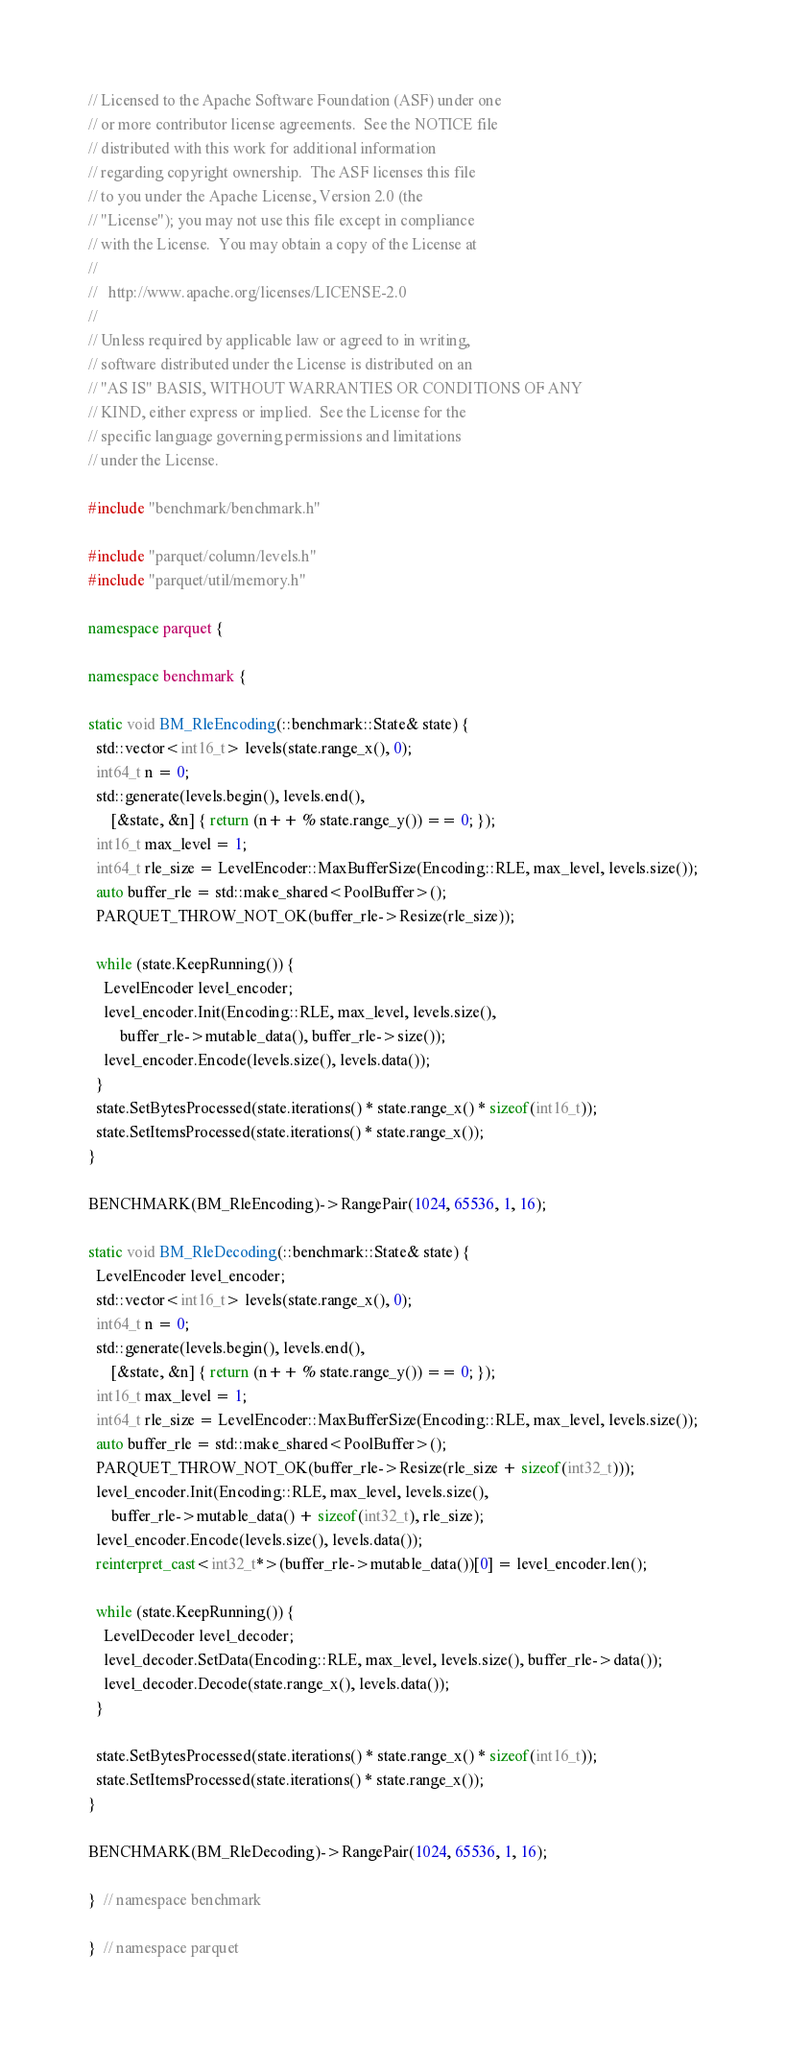<code> <loc_0><loc_0><loc_500><loc_500><_C++_>// Licensed to the Apache Software Foundation (ASF) under one
// or more contributor license agreements.  See the NOTICE file
// distributed with this work for additional information
// regarding copyright ownership.  The ASF licenses this file
// to you under the Apache License, Version 2.0 (the
// "License"); you may not use this file except in compliance
// with the License.  You may obtain a copy of the License at
//
//   http://www.apache.org/licenses/LICENSE-2.0
//
// Unless required by applicable law or agreed to in writing,
// software distributed under the License is distributed on an
// "AS IS" BASIS, WITHOUT WARRANTIES OR CONDITIONS OF ANY
// KIND, either express or implied.  See the License for the
// specific language governing permissions and limitations
// under the License.

#include "benchmark/benchmark.h"

#include "parquet/column/levels.h"
#include "parquet/util/memory.h"

namespace parquet {

namespace benchmark {

static void BM_RleEncoding(::benchmark::State& state) {
  std::vector<int16_t> levels(state.range_x(), 0);
  int64_t n = 0;
  std::generate(levels.begin(), levels.end(),
      [&state, &n] { return (n++ % state.range_y()) == 0; });
  int16_t max_level = 1;
  int64_t rle_size = LevelEncoder::MaxBufferSize(Encoding::RLE, max_level, levels.size());
  auto buffer_rle = std::make_shared<PoolBuffer>();
  PARQUET_THROW_NOT_OK(buffer_rle->Resize(rle_size));

  while (state.KeepRunning()) {
    LevelEncoder level_encoder;
    level_encoder.Init(Encoding::RLE, max_level, levels.size(),
        buffer_rle->mutable_data(), buffer_rle->size());
    level_encoder.Encode(levels.size(), levels.data());
  }
  state.SetBytesProcessed(state.iterations() * state.range_x() * sizeof(int16_t));
  state.SetItemsProcessed(state.iterations() * state.range_x());
}

BENCHMARK(BM_RleEncoding)->RangePair(1024, 65536, 1, 16);

static void BM_RleDecoding(::benchmark::State& state) {
  LevelEncoder level_encoder;
  std::vector<int16_t> levels(state.range_x(), 0);
  int64_t n = 0;
  std::generate(levels.begin(), levels.end(),
      [&state, &n] { return (n++ % state.range_y()) == 0; });
  int16_t max_level = 1;
  int64_t rle_size = LevelEncoder::MaxBufferSize(Encoding::RLE, max_level, levels.size());
  auto buffer_rle = std::make_shared<PoolBuffer>();
  PARQUET_THROW_NOT_OK(buffer_rle->Resize(rle_size + sizeof(int32_t)));
  level_encoder.Init(Encoding::RLE, max_level, levels.size(),
      buffer_rle->mutable_data() + sizeof(int32_t), rle_size);
  level_encoder.Encode(levels.size(), levels.data());
  reinterpret_cast<int32_t*>(buffer_rle->mutable_data())[0] = level_encoder.len();

  while (state.KeepRunning()) {
    LevelDecoder level_decoder;
    level_decoder.SetData(Encoding::RLE, max_level, levels.size(), buffer_rle->data());
    level_decoder.Decode(state.range_x(), levels.data());
  }

  state.SetBytesProcessed(state.iterations() * state.range_x() * sizeof(int16_t));
  state.SetItemsProcessed(state.iterations() * state.range_x());
}

BENCHMARK(BM_RleDecoding)->RangePair(1024, 65536, 1, 16);

}  // namespace benchmark

}  // namespace parquet
</code> 